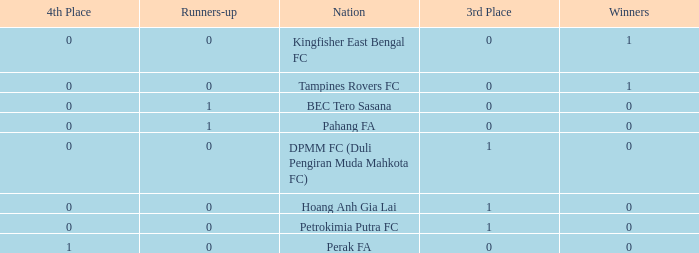Name the highest 3rd place for nation of perak fa 0.0. 